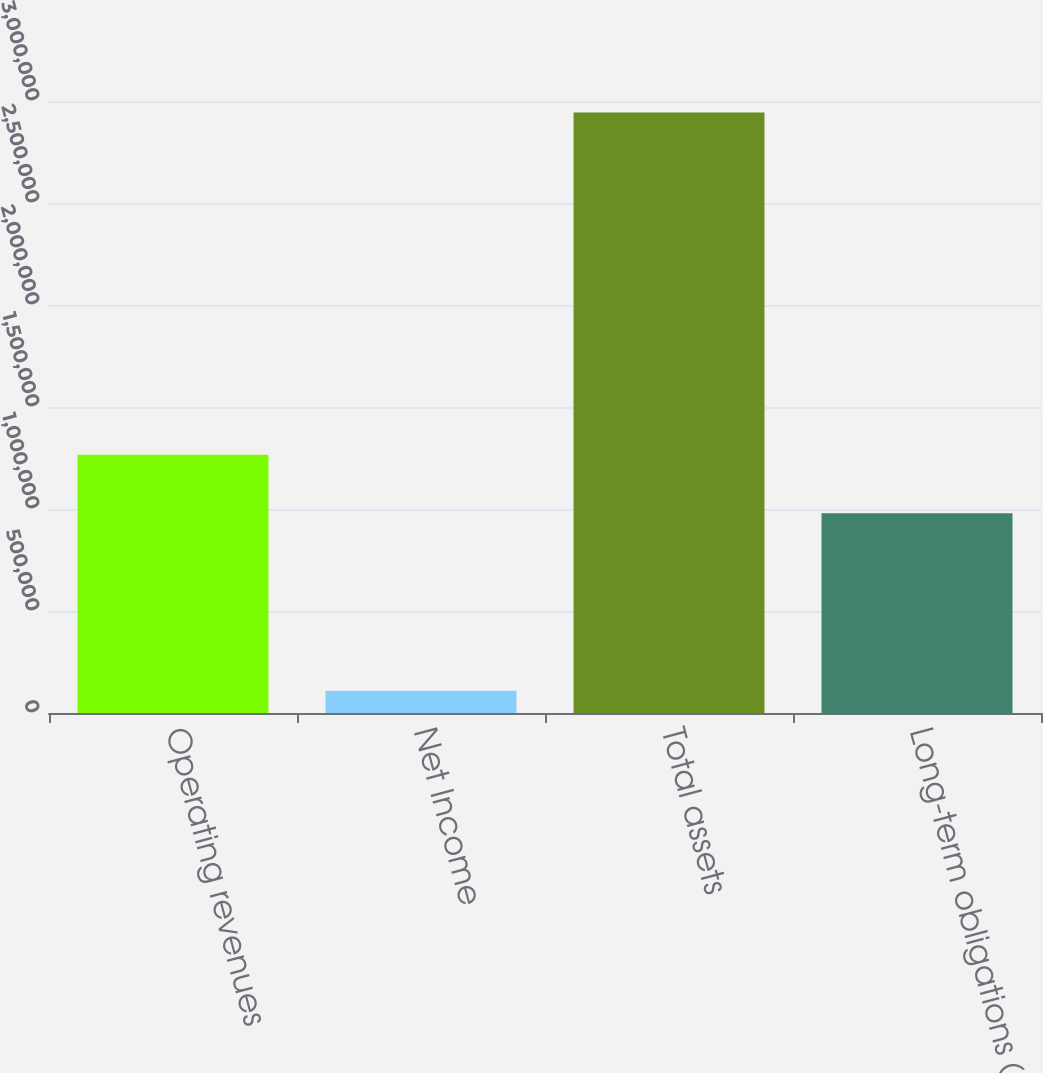Convert chart. <chart><loc_0><loc_0><loc_500><loc_500><bar_chart><fcel>Operating revenues<fcel>Net Income<fcel>Total assets<fcel>Long-term obligations (1)<nl><fcel>1.26647e+06<fcel>108729<fcel>2.94339e+06<fcel>978932<nl></chart> 